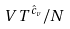Convert formula to latex. <formula><loc_0><loc_0><loc_500><loc_500>V T ^ { \hat { c } _ { v } } / N</formula> 